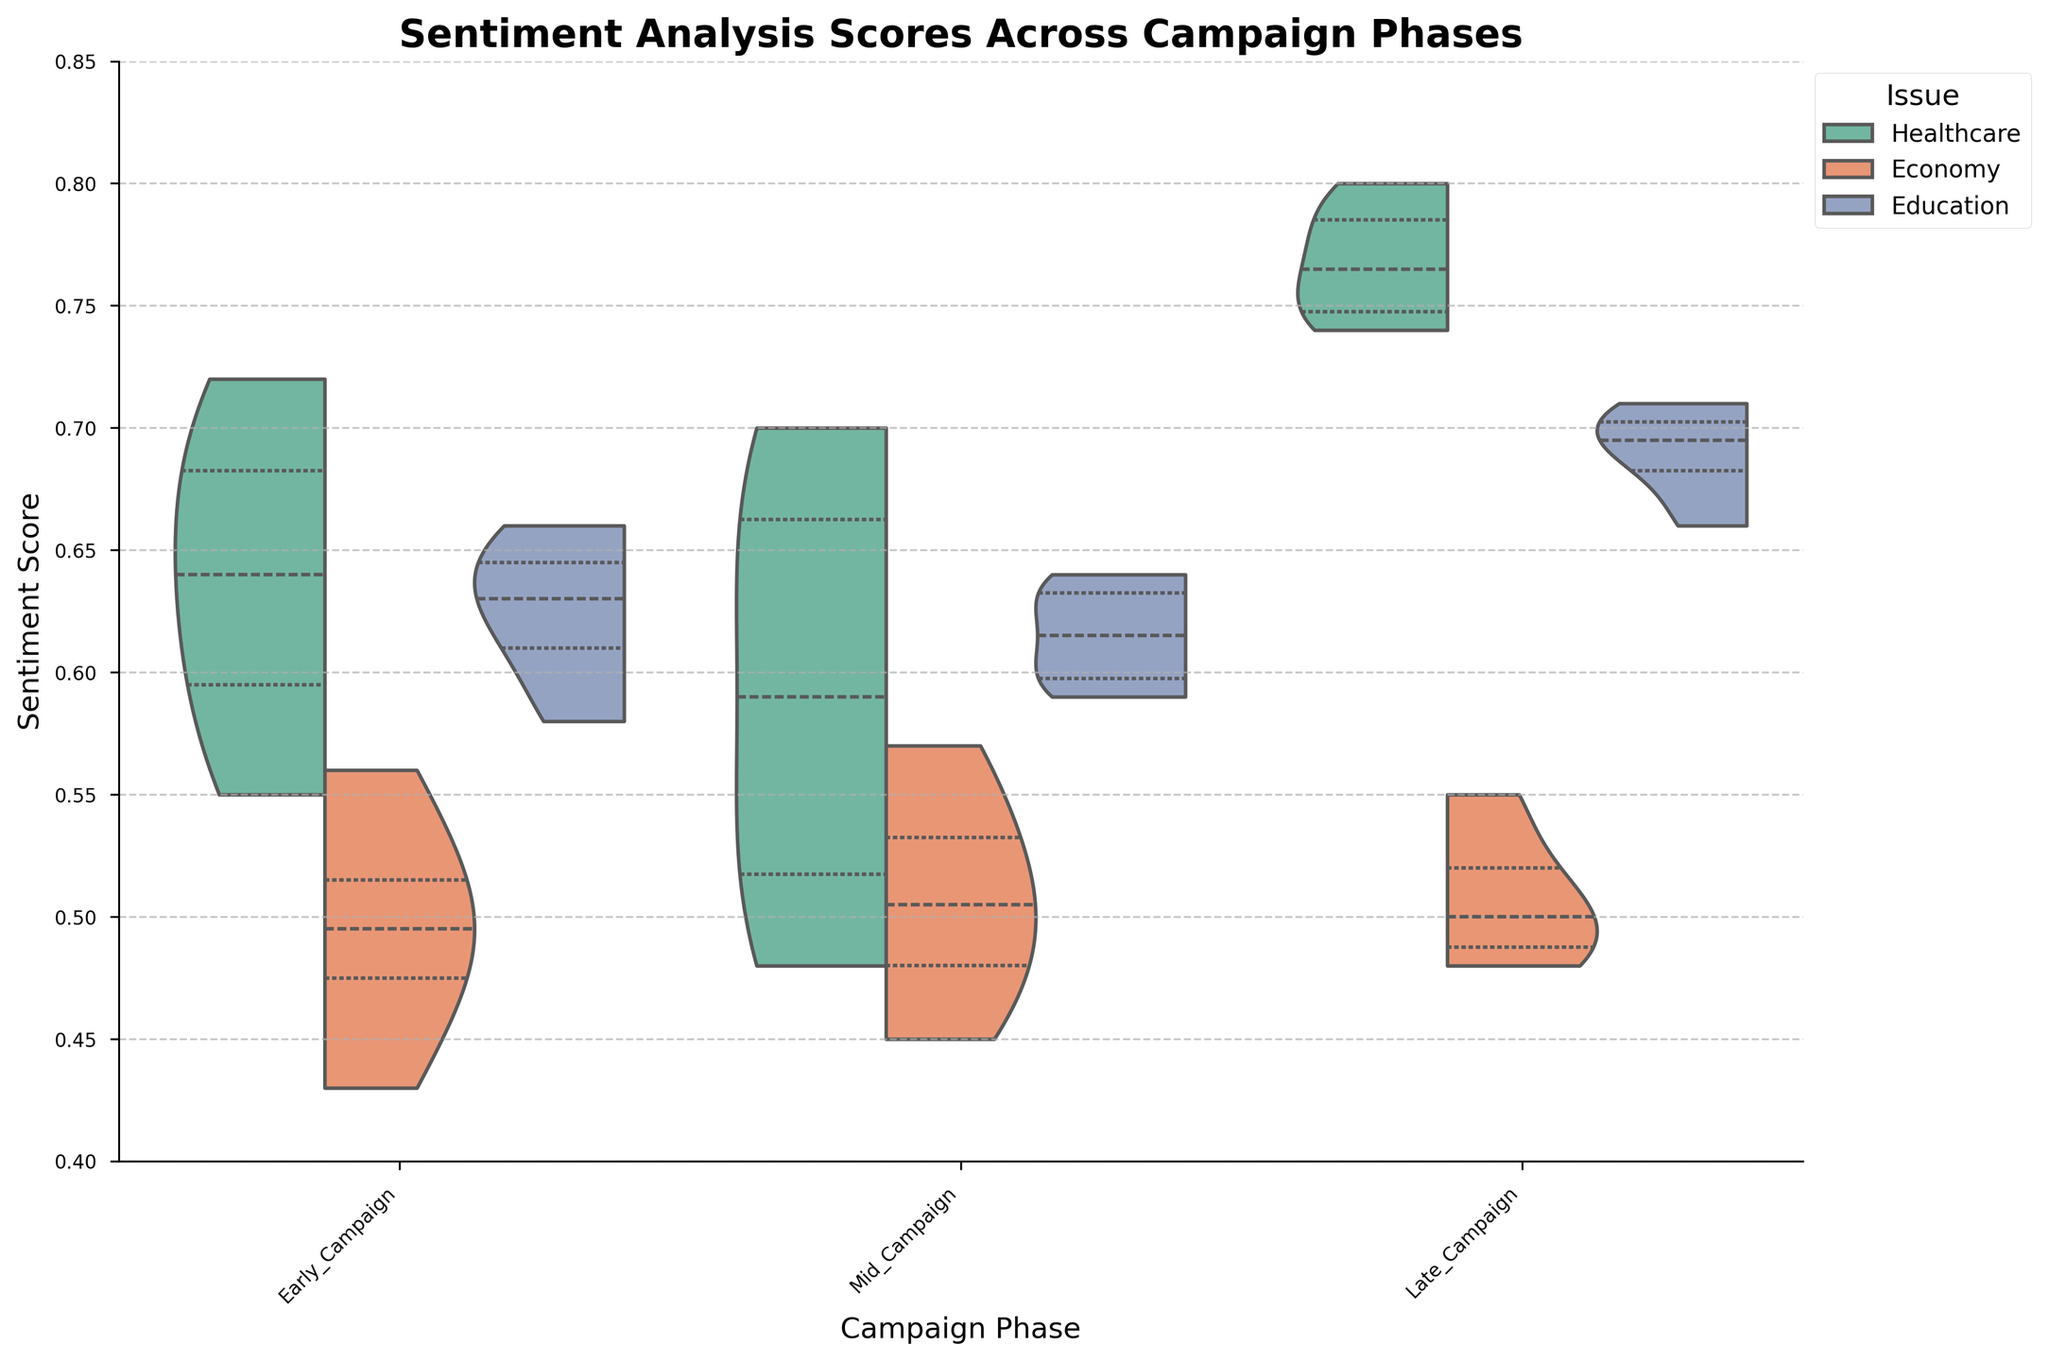What is the title of the plot? The title can be found at the top of the plot, displayed prominently.
Answer: Sentiment Analysis Scores Across Campaign Phases What does the y-axis represent? The y-axis label on the plot provides this information.
Answer: Sentiment Score How many campaign phases are there in the plot? Count the distinct categories along the x-axis.
Answer: Three What sentiment scores are displayed for Healthcare during the Early Campaign phase? Locate the Early Campaign phase on the x-axis and observe the segments related to Healthcare in the violin plot.
Answer: Approximately between 0.55 and 0.72 Which issue has the highest median sentiment score during the Late Campaign phase? Analyze the median lines inside the violin plots for each issue during the Late Campaign phase.
Answer: Healthcare Which phase shows the widest range of sentiment scores for the Economy issue? Compare the range (difference between the maximum and minimum values) of sentiment scores for the Economy issue across all phases.
Answer: Early Campaign What is the general trend of the sentiment scores for Healthcare across all campaign phases? Observe the changes in the position and spread of the Healthcare sentiment scores across the Early, Mid, and Late Campaign phases.
Answer: Increasing trend During which campaign phase is the sentiment score for Education the most consistent? Compare the spread and variation of the sentiment scores for Education across all campaign phases; a more consistent score would show less spread.
Answer: Mid Campaign Is the overall sentiment score for the Economy issue higher in the Mid Campaign phase compared to the Early Campaign phase? Compare the central tendency (such as the median line) of the sentiment scores for the Economy issue between the Mid Campaign and Early Campaign phases.
Answer: Yes 